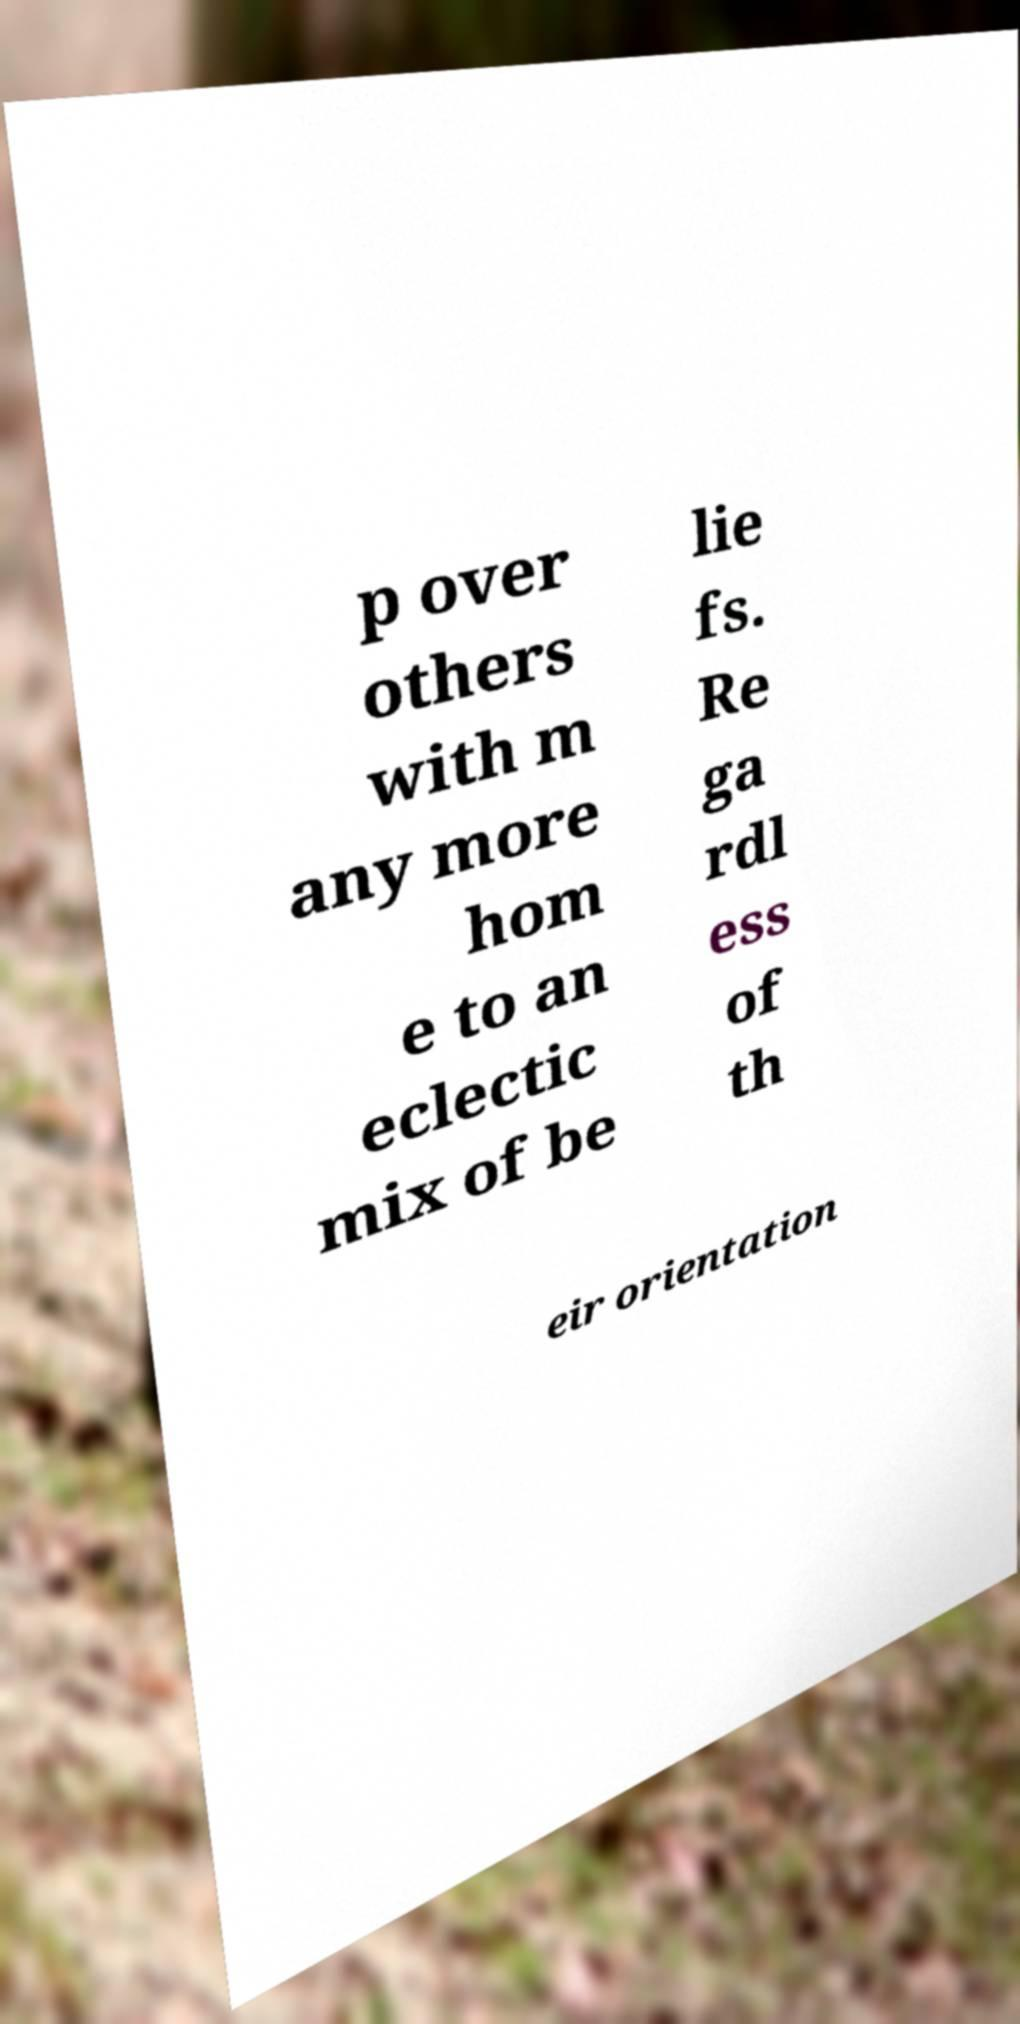Please identify and transcribe the text found in this image. p over others with m any more hom e to an eclectic mix of be lie fs. Re ga rdl ess of th eir orientation 